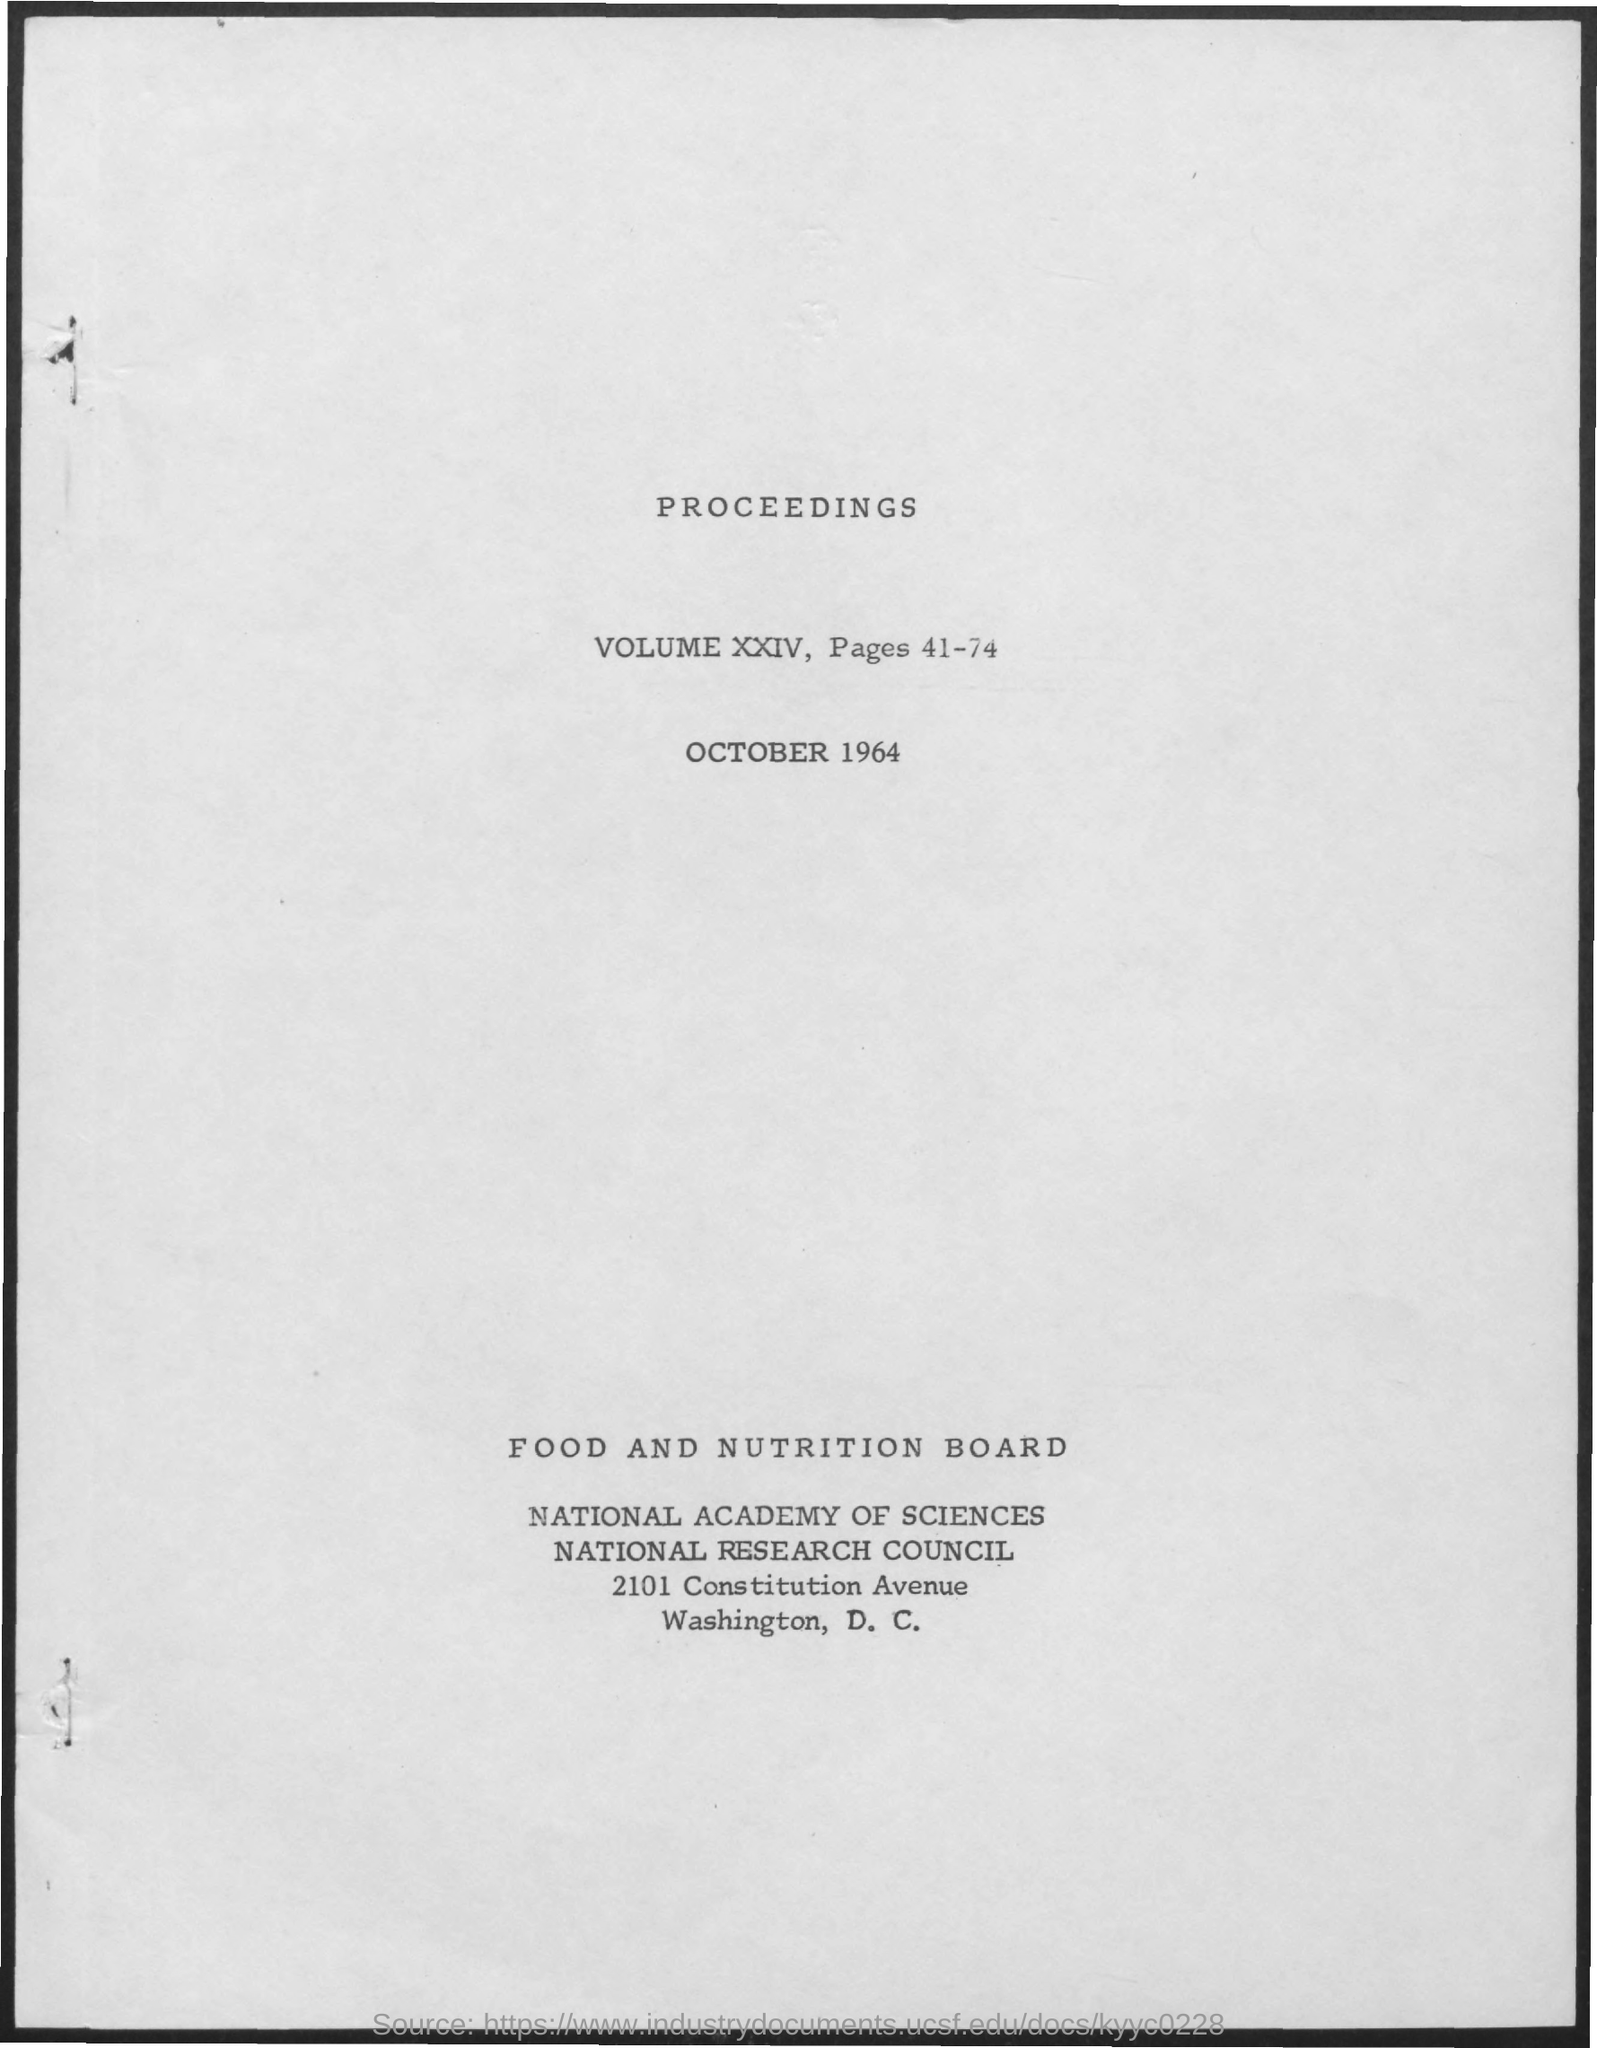List a handful of essential elements in this visual. The volume number of the proceedings is XXIV. The proceedings can be found on page 41 through 74. 